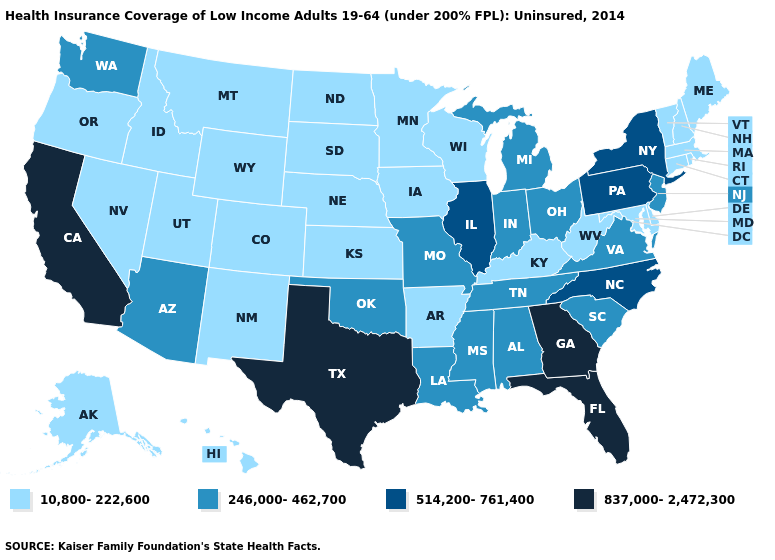Name the states that have a value in the range 837,000-2,472,300?
Give a very brief answer. California, Florida, Georgia, Texas. Does South Dakota have a lower value than Wyoming?
Write a very short answer. No. Does the first symbol in the legend represent the smallest category?
Give a very brief answer. Yes. How many symbols are there in the legend?
Give a very brief answer. 4. Does Tennessee have a lower value than New York?
Be succinct. Yes. What is the lowest value in the USA?
Concise answer only. 10,800-222,600. Name the states that have a value in the range 10,800-222,600?
Keep it brief. Alaska, Arkansas, Colorado, Connecticut, Delaware, Hawaii, Idaho, Iowa, Kansas, Kentucky, Maine, Maryland, Massachusetts, Minnesota, Montana, Nebraska, Nevada, New Hampshire, New Mexico, North Dakota, Oregon, Rhode Island, South Dakota, Utah, Vermont, West Virginia, Wisconsin, Wyoming. Name the states that have a value in the range 246,000-462,700?
Short answer required. Alabama, Arizona, Indiana, Louisiana, Michigan, Mississippi, Missouri, New Jersey, Ohio, Oklahoma, South Carolina, Tennessee, Virginia, Washington. Which states have the lowest value in the MidWest?
Short answer required. Iowa, Kansas, Minnesota, Nebraska, North Dakota, South Dakota, Wisconsin. Name the states that have a value in the range 10,800-222,600?
Write a very short answer. Alaska, Arkansas, Colorado, Connecticut, Delaware, Hawaii, Idaho, Iowa, Kansas, Kentucky, Maine, Maryland, Massachusetts, Minnesota, Montana, Nebraska, Nevada, New Hampshire, New Mexico, North Dakota, Oregon, Rhode Island, South Dakota, Utah, Vermont, West Virginia, Wisconsin, Wyoming. Name the states that have a value in the range 246,000-462,700?
Keep it brief. Alabama, Arizona, Indiana, Louisiana, Michigan, Mississippi, Missouri, New Jersey, Ohio, Oklahoma, South Carolina, Tennessee, Virginia, Washington. What is the value of California?
Concise answer only. 837,000-2,472,300. What is the highest value in the West ?
Short answer required. 837,000-2,472,300. Among the states that border Maryland , does Virginia have the highest value?
Quick response, please. No. 